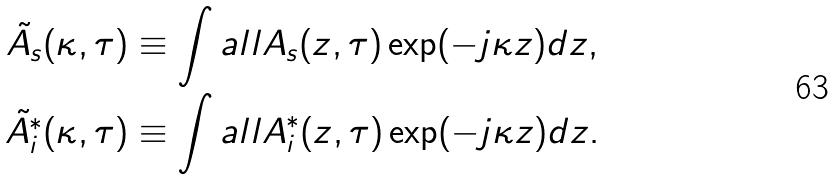Convert formula to latex. <formula><loc_0><loc_0><loc_500><loc_500>\tilde { A _ { s } } ( \kappa , \tau ) & \equiv \int a l l A _ { s } ( z , \tau ) \exp ( - j \kappa z ) d z , \\ \tilde { A _ { i } ^ { * } } ( \kappa , \tau ) & \equiv \int a l l A _ { i } ^ { * } ( z , \tau ) \exp ( - j \kappa z ) d z .</formula> 